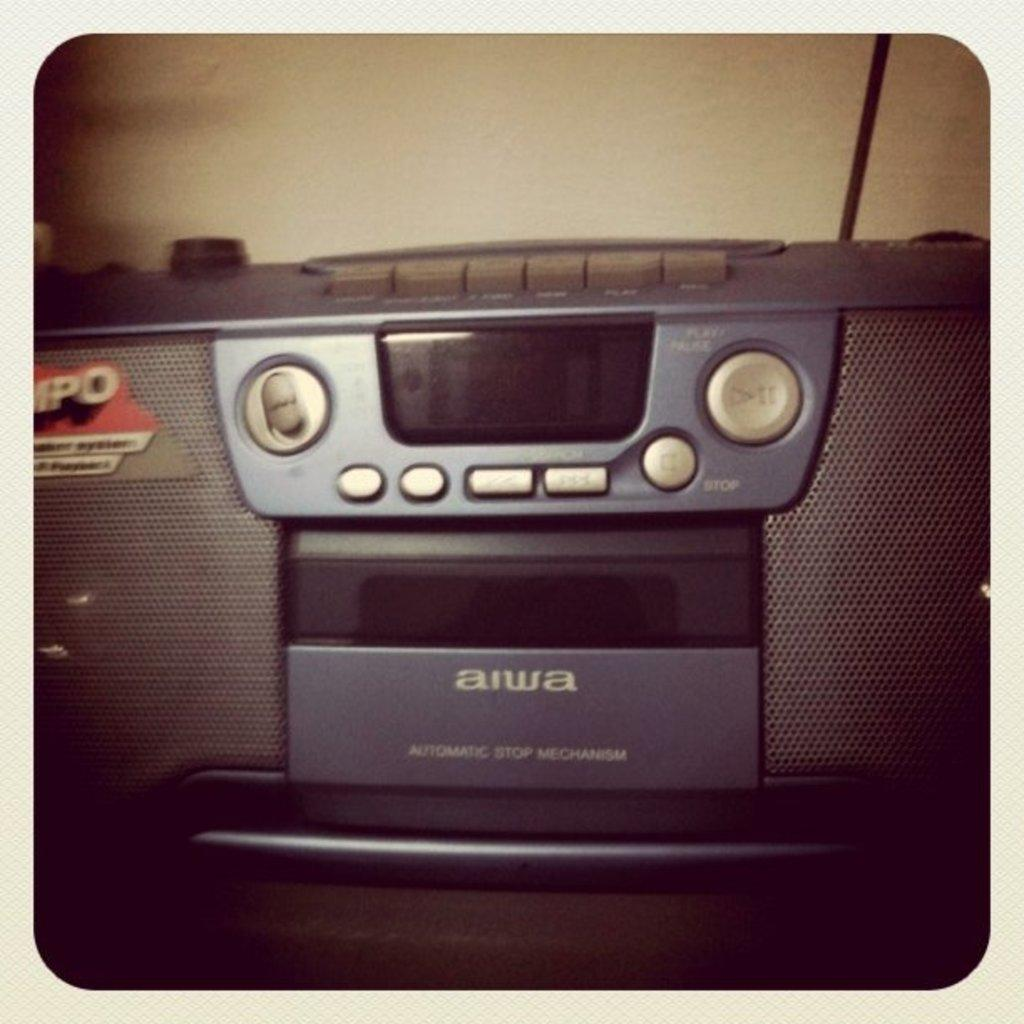What device is the main subject of the image? There is a tape recorder in the image. What can be seen in the background of the image? There is a cable and a wall in the background of the image. What type of credit card is being used at the party in the image? There is no credit card or party present in the image; it only features a tape recorder and a cable in the background. 